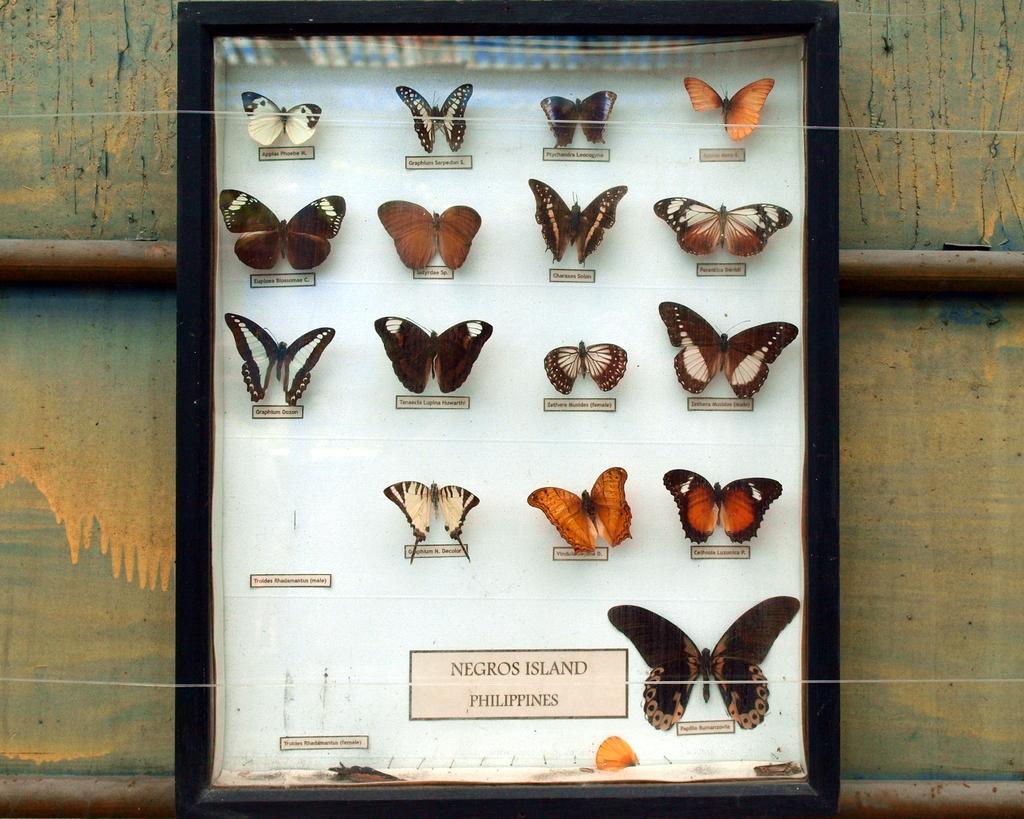Please provide a concise description of this image. In this picture I can see butterflies with names in a glass box, and in the background there are iron rods and a wall. 